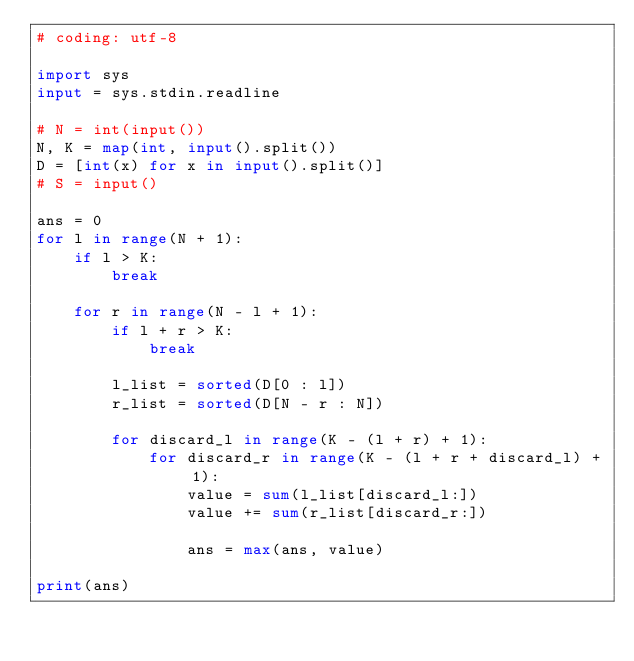Convert code to text. <code><loc_0><loc_0><loc_500><loc_500><_Python_># coding: utf-8

import sys
input = sys.stdin.readline

# N = int(input())
N, K = map(int, input().split())
D = [int(x) for x in input().split()]
# S = input()

ans = 0
for l in range(N + 1):
    if l > K:
        break

    for r in range(N - l + 1):
        if l + r > K:
            break

        l_list = sorted(D[0 : l])
        r_list = sorted(D[N - r : N])

        for discard_l in range(K - (l + r) + 1):
            for discard_r in range(K - (l + r + discard_l) + 1):
                value = sum(l_list[discard_l:])
                value += sum(r_list[discard_r:])

                ans = max(ans, value)
        
print(ans)
</code> 